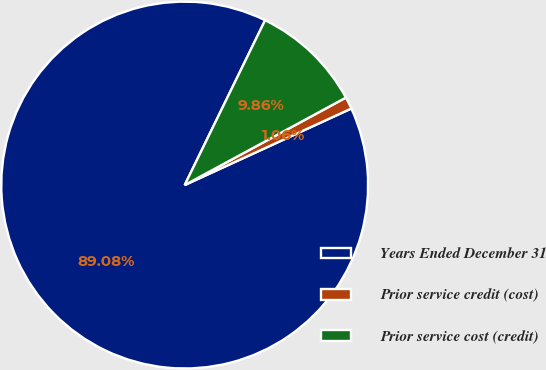<chart> <loc_0><loc_0><loc_500><loc_500><pie_chart><fcel>Years Ended December 31<fcel>Prior service credit (cost)<fcel>Prior service cost (credit)<nl><fcel>89.07%<fcel>1.06%<fcel>9.86%<nl></chart> 